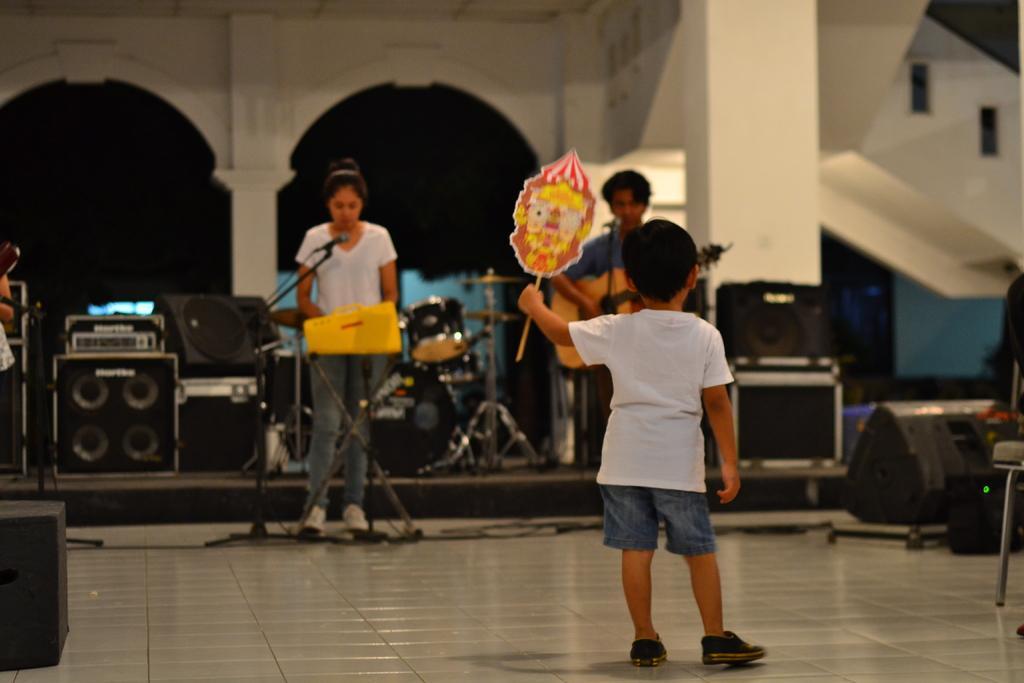In one or two sentences, can you explain what this image depicts? This image is taken indoors. At the bottom of the image there is a floor. In the background there is a wall and there are a few pillars and a staircase. There are many musical instruments and speakers on the floor. In the middle of the image a girl is standing on the floor and there is a mic and a man is standing on the floor and holding a guitar in his hands and a kid is standing on the floor. 